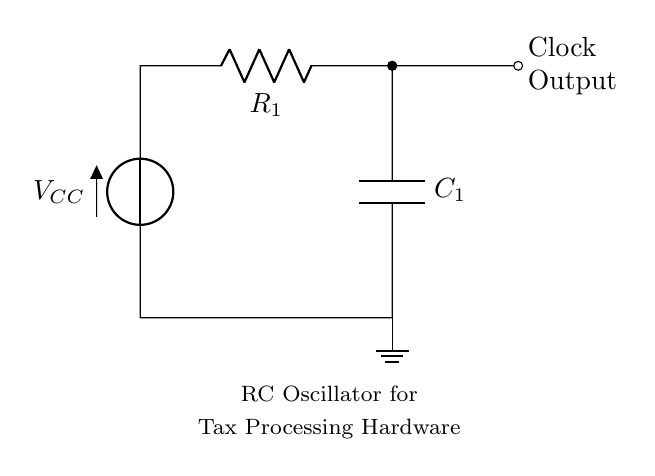What is the supply voltage in the circuit? The supply voltage is indicated by the voltage source labeled Vcc at the top of the circuit diagram. This component provides the necessary voltage for the operation of the circuit.
Answer: Vcc What type of oscillator is depicted in the circuit? The circuit diagram shows a resistor-capacitor (RC) oscillator. The presence of a resistor and capacitor in the feedback loop is characteristic of an RC oscillator, which generates a continuous oscillating signal.
Answer: RC oscillator What is the function of the capacitor in this circuit? The capacitor in this RC oscillator circuit serves to store electrical energy and create a phase shift between the voltage across it and the current flowing through it, which is essential for the generation of an oscillating clock signal.
Answer: Store energy What are the connection points for R1 and C1 in the circuit? Resistor R1 connects from the positive voltage supply (Vcc) to the node at the top right connecting to C1, while C1 connects from that same node down to ground. This shows the series connection of R1 and C1 in the circuit to create the oscillation.
Answer: Vcc and ground How does the output clock signal get generated in this RC oscillator? The clock signal is produced as a result of the charging and discharging cycles of capacitor C1, which are controlled by resistor R1. As C1 charges through R1, the voltage across it changes, causing it to oscillate between high and low states, which is observed at the clock output.
Answer: Oscillation of C1 